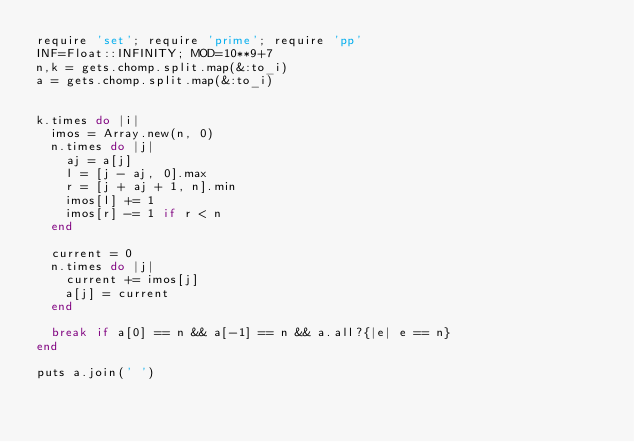<code> <loc_0><loc_0><loc_500><loc_500><_Ruby_>require 'set'; require 'prime'; require 'pp'
INF=Float::INFINITY; MOD=10**9+7
n,k = gets.chomp.split.map(&:to_i)
a = gets.chomp.split.map(&:to_i)


k.times do |i|
  imos = Array.new(n, 0)
  n.times do |j|
    aj = a[j]
    l = [j - aj, 0].max
    r = [j + aj + 1, n].min
    imos[l] += 1
    imos[r] -= 1 if r < n
  end

  current = 0
  n.times do |j|
    current += imos[j]
    a[j] = current
  end

  break if a[0] == n && a[-1] == n && a.all?{|e| e == n}
end

puts a.join(' ')

</code> 